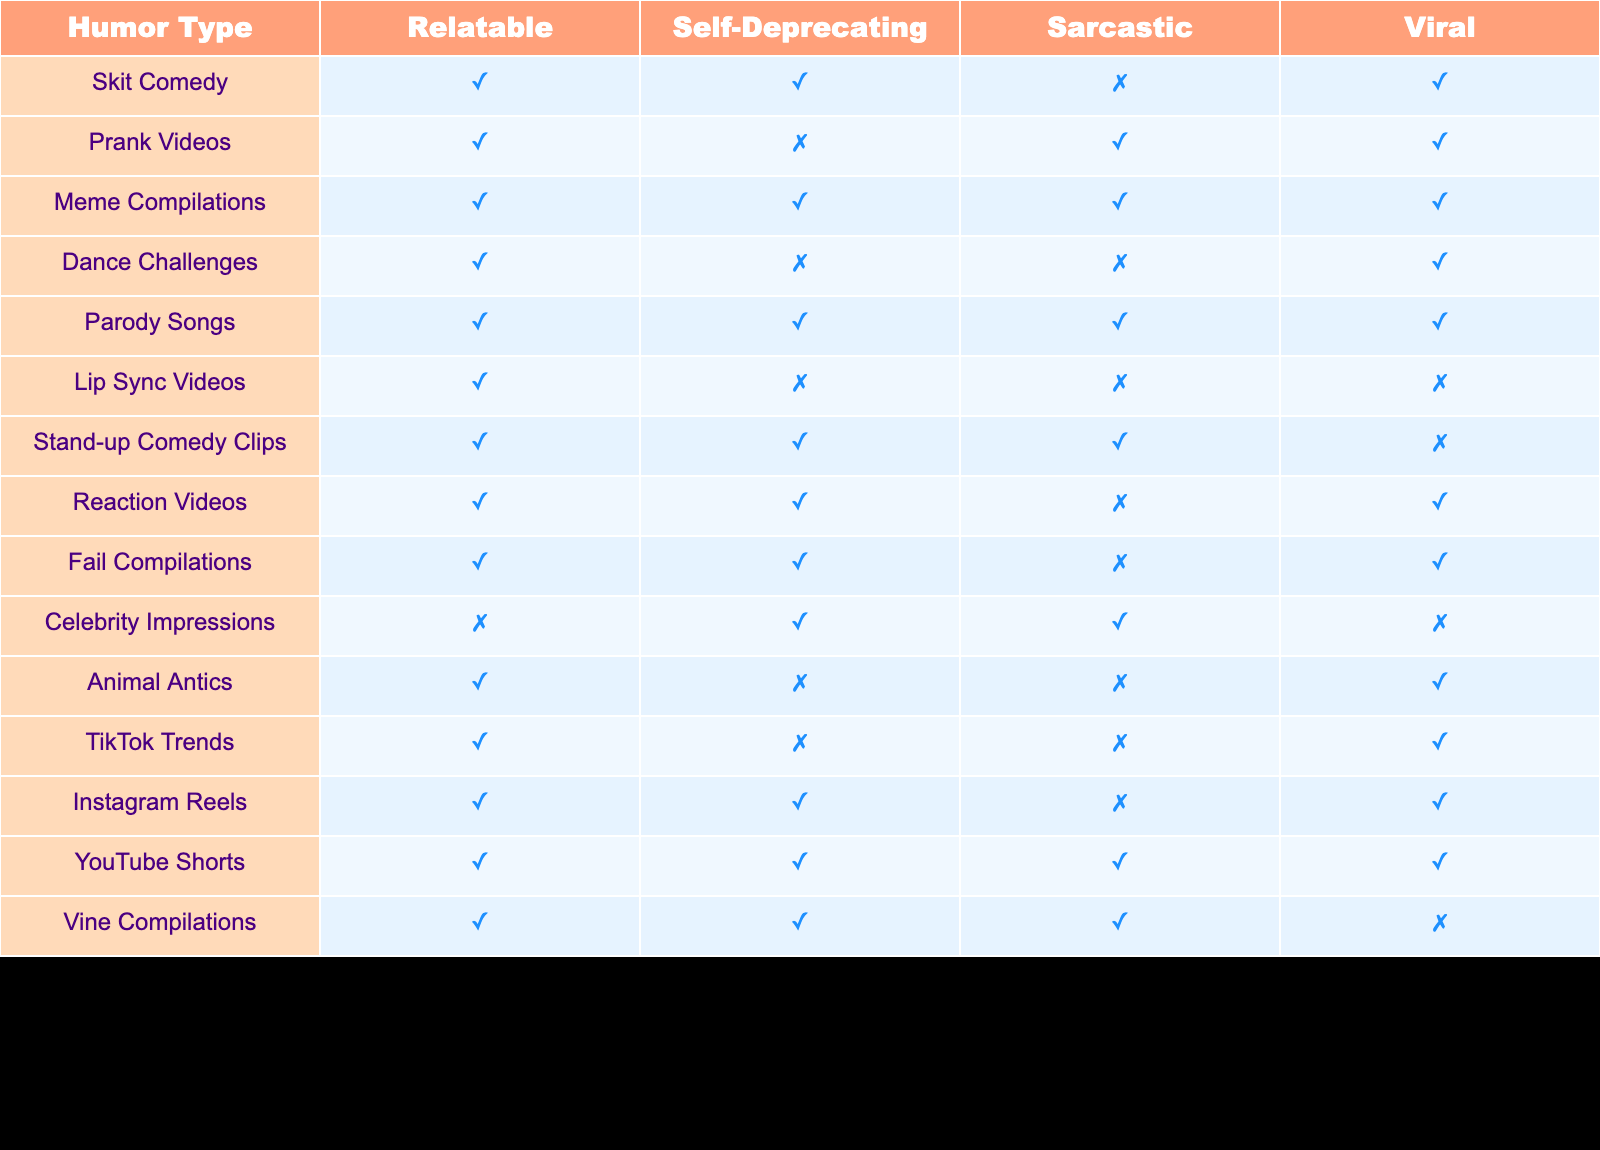What type of humor is both relatable and self-deprecating? By reviewing the table, we look for humor types where both "Relatable" and "Self-Deprecating" are marked as true (✓). The humor types that have both these traits are Skit Comedy, Meme Compilations, Parody Songs, Stand-up Comedy Clips, and Reaction Videos.
Answer: Skit Comedy, Meme Compilations, Parody Songs, Stand-up Comedy Clips, Reaction Videos Which humor type is not viral but is relatable and self-deprecating? We need to find a humor type that has "Relatable" as true (✓), "Self-Deprecating" as true (✓), but "Viral" as false (✗). The only humor type that meets these criteria is Stand-up Comedy Clips.
Answer: Stand-up Comedy Clips How many humor types are categorized as relatable? We can count the number of humor types with the "Relatable" column marked as true (✓). Looking through the table, we find 13 humor types that are relatable.
Answer: 13 Is Animal Antics a type of humor that is sarcastic? We can check the "Sarcastic" column for Animal Antics, which is marked as false (✗). So, the answer to whether it is sarcastic is no.
Answer: No Which humor type has the most types of humor characteristics (relatable, self-deprecating, sarcastic)? We look for the rows with true (✓) values across all three columns: "Relatable," "Self-Deprecating," and "Sarcastic." The humor types that meet these criteria are Meme Compilations and Parody Songs, both having all three marked as true.
Answer: Meme Compilations, Parody Songs How does the number of viral humor types with self-deprecating humor compare to those that are sarcastic? First, we find the number of viral humor types that are self-deprecating: Skit Comedy, Meme Compilations, and Parody Songs, giving us 3. Next, we find viral humor types that are sarcastic: Prank Videos and Reaction Videos, giving us 2. Therefore, the comparison shows that there are more viral humor types with self-deprecating humor than sarcastic humor types.
Answer: More self-deprecating humor types Are there any dance challenges that are viral? Checking the "Dance Challenges" row, we find that its "Viral" status is marked as true (✓).
Answer: Yes Which humor type has the least characteristics and is also not viral? To determine this, we check humor types with the most false (✗) characteristics and also ensure they are marked as not viral. Lip Sync Videos have no characteristics marked as true, and they are marked as not viral.
Answer: Lip Sync Videos What is the percentage of viral humor types among all types of humor? There are 14 humor types total, and 8 of them are viral. To calculate the percentage, we divide 8 by 14 and multiply by 100, resulting in approximately 57.14%.
Answer: 57.14% 